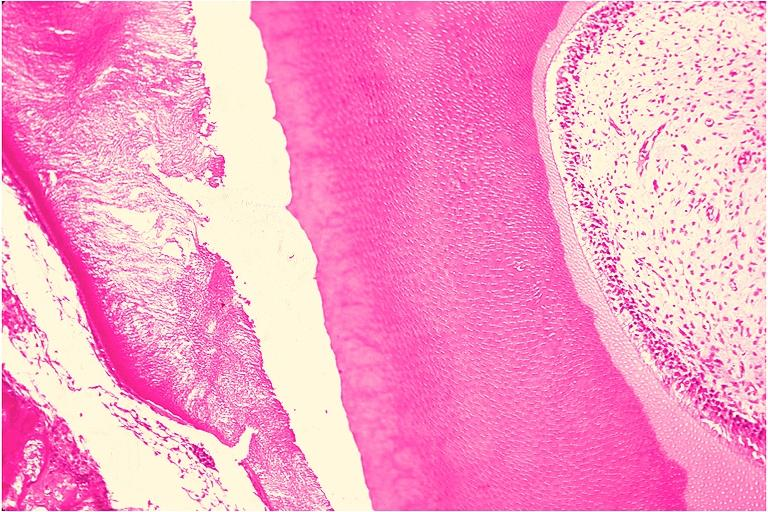where is this?
Answer the question using a single word or phrase. Oral 